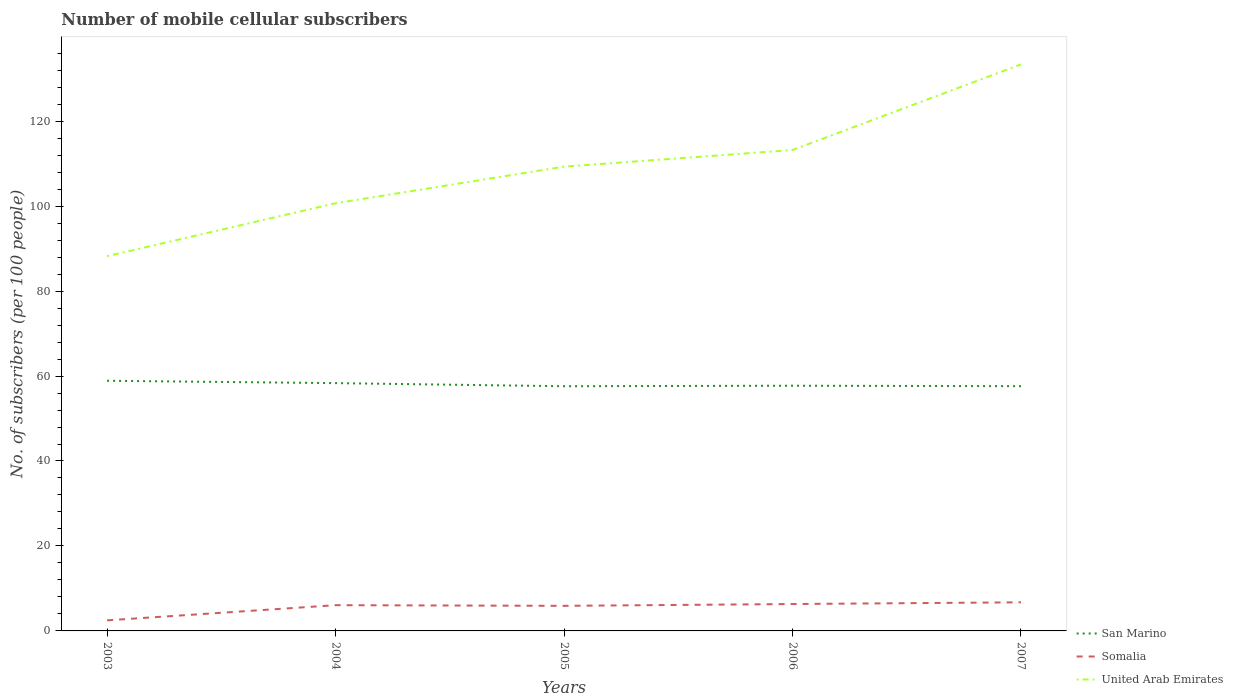How many different coloured lines are there?
Provide a succinct answer. 3. Across all years, what is the maximum number of mobile cellular subscribers in United Arab Emirates?
Your answer should be compact. 88.22. In which year was the number of mobile cellular subscribers in Somalia maximum?
Keep it short and to the point. 2003. What is the total number of mobile cellular subscribers in Somalia in the graph?
Your answer should be very brief. -3.42. What is the difference between the highest and the second highest number of mobile cellular subscribers in San Marino?
Your response must be concise. 1.29. What is the difference between the highest and the lowest number of mobile cellular subscribers in Somalia?
Your answer should be very brief. 4. How many years are there in the graph?
Your response must be concise. 5. Where does the legend appear in the graph?
Give a very brief answer. Bottom right. How are the legend labels stacked?
Keep it short and to the point. Vertical. What is the title of the graph?
Offer a terse response. Number of mobile cellular subscribers. What is the label or title of the X-axis?
Your answer should be very brief. Years. What is the label or title of the Y-axis?
Ensure brevity in your answer.  No. of subscribers (per 100 people). What is the No. of subscribers (per 100 people) of San Marino in 2003?
Give a very brief answer. 58.89. What is the No. of subscribers (per 100 people) in Somalia in 2003?
Provide a succinct answer. 2.49. What is the No. of subscribers (per 100 people) of United Arab Emirates in 2003?
Your answer should be compact. 88.22. What is the No. of subscribers (per 100 people) in San Marino in 2004?
Your answer should be very brief. 58.33. What is the No. of subscribers (per 100 people) of Somalia in 2004?
Ensure brevity in your answer.  6.06. What is the No. of subscribers (per 100 people) in United Arab Emirates in 2004?
Provide a succinct answer. 100.67. What is the No. of subscribers (per 100 people) in San Marino in 2005?
Your answer should be very brief. 57.6. What is the No. of subscribers (per 100 people) in Somalia in 2005?
Ensure brevity in your answer.  5.91. What is the No. of subscribers (per 100 people) of United Arab Emirates in 2005?
Your response must be concise. 109.29. What is the No. of subscribers (per 100 people) in San Marino in 2006?
Ensure brevity in your answer.  57.72. What is the No. of subscribers (per 100 people) in Somalia in 2006?
Give a very brief answer. 6.33. What is the No. of subscribers (per 100 people) of United Arab Emirates in 2006?
Give a very brief answer. 113.2. What is the No. of subscribers (per 100 people) in San Marino in 2007?
Provide a succinct answer. 57.61. What is the No. of subscribers (per 100 people) in Somalia in 2007?
Make the answer very short. 6.73. What is the No. of subscribers (per 100 people) of United Arab Emirates in 2007?
Your answer should be compact. 133.36. Across all years, what is the maximum No. of subscribers (per 100 people) of San Marino?
Your answer should be very brief. 58.89. Across all years, what is the maximum No. of subscribers (per 100 people) of Somalia?
Offer a very short reply. 6.73. Across all years, what is the maximum No. of subscribers (per 100 people) of United Arab Emirates?
Your answer should be compact. 133.36. Across all years, what is the minimum No. of subscribers (per 100 people) of San Marino?
Ensure brevity in your answer.  57.6. Across all years, what is the minimum No. of subscribers (per 100 people) of Somalia?
Provide a succinct answer. 2.49. Across all years, what is the minimum No. of subscribers (per 100 people) of United Arab Emirates?
Offer a terse response. 88.22. What is the total No. of subscribers (per 100 people) of San Marino in the graph?
Offer a very short reply. 290.14. What is the total No. of subscribers (per 100 people) of Somalia in the graph?
Your answer should be compact. 27.52. What is the total No. of subscribers (per 100 people) in United Arab Emirates in the graph?
Make the answer very short. 544.74. What is the difference between the No. of subscribers (per 100 people) of San Marino in 2003 and that in 2004?
Offer a terse response. 0.55. What is the difference between the No. of subscribers (per 100 people) of Somalia in 2003 and that in 2004?
Make the answer very short. -3.57. What is the difference between the No. of subscribers (per 100 people) of United Arab Emirates in 2003 and that in 2004?
Provide a succinct answer. -12.45. What is the difference between the No. of subscribers (per 100 people) in San Marino in 2003 and that in 2005?
Your response must be concise. 1.29. What is the difference between the No. of subscribers (per 100 people) in Somalia in 2003 and that in 2005?
Offer a terse response. -3.42. What is the difference between the No. of subscribers (per 100 people) of United Arab Emirates in 2003 and that in 2005?
Your response must be concise. -21.07. What is the difference between the No. of subscribers (per 100 people) in San Marino in 2003 and that in 2006?
Make the answer very short. 1.17. What is the difference between the No. of subscribers (per 100 people) in Somalia in 2003 and that in 2006?
Your answer should be very brief. -3.84. What is the difference between the No. of subscribers (per 100 people) of United Arab Emirates in 2003 and that in 2006?
Provide a short and direct response. -24.98. What is the difference between the No. of subscribers (per 100 people) in San Marino in 2003 and that in 2007?
Your response must be concise. 1.28. What is the difference between the No. of subscribers (per 100 people) of Somalia in 2003 and that in 2007?
Your answer should be compact. -4.25. What is the difference between the No. of subscribers (per 100 people) in United Arab Emirates in 2003 and that in 2007?
Your response must be concise. -45.14. What is the difference between the No. of subscribers (per 100 people) of San Marino in 2004 and that in 2005?
Ensure brevity in your answer.  0.73. What is the difference between the No. of subscribers (per 100 people) in Somalia in 2004 and that in 2005?
Your response must be concise. 0.16. What is the difference between the No. of subscribers (per 100 people) of United Arab Emirates in 2004 and that in 2005?
Offer a very short reply. -8.62. What is the difference between the No. of subscribers (per 100 people) of San Marino in 2004 and that in 2006?
Keep it short and to the point. 0.61. What is the difference between the No. of subscribers (per 100 people) in Somalia in 2004 and that in 2006?
Offer a terse response. -0.27. What is the difference between the No. of subscribers (per 100 people) in United Arab Emirates in 2004 and that in 2006?
Your answer should be compact. -12.53. What is the difference between the No. of subscribers (per 100 people) in San Marino in 2004 and that in 2007?
Your answer should be very brief. 0.72. What is the difference between the No. of subscribers (per 100 people) of Somalia in 2004 and that in 2007?
Your answer should be very brief. -0.67. What is the difference between the No. of subscribers (per 100 people) of United Arab Emirates in 2004 and that in 2007?
Make the answer very short. -32.69. What is the difference between the No. of subscribers (per 100 people) of San Marino in 2005 and that in 2006?
Keep it short and to the point. -0.12. What is the difference between the No. of subscribers (per 100 people) in Somalia in 2005 and that in 2006?
Offer a very short reply. -0.43. What is the difference between the No. of subscribers (per 100 people) of United Arab Emirates in 2005 and that in 2006?
Offer a terse response. -3.92. What is the difference between the No. of subscribers (per 100 people) in San Marino in 2005 and that in 2007?
Offer a very short reply. -0.01. What is the difference between the No. of subscribers (per 100 people) in Somalia in 2005 and that in 2007?
Ensure brevity in your answer.  -0.83. What is the difference between the No. of subscribers (per 100 people) in United Arab Emirates in 2005 and that in 2007?
Your response must be concise. -24.08. What is the difference between the No. of subscribers (per 100 people) in San Marino in 2006 and that in 2007?
Provide a short and direct response. 0.11. What is the difference between the No. of subscribers (per 100 people) in Somalia in 2006 and that in 2007?
Provide a short and direct response. -0.4. What is the difference between the No. of subscribers (per 100 people) in United Arab Emirates in 2006 and that in 2007?
Provide a short and direct response. -20.16. What is the difference between the No. of subscribers (per 100 people) in San Marino in 2003 and the No. of subscribers (per 100 people) in Somalia in 2004?
Offer a terse response. 52.82. What is the difference between the No. of subscribers (per 100 people) of San Marino in 2003 and the No. of subscribers (per 100 people) of United Arab Emirates in 2004?
Offer a terse response. -41.78. What is the difference between the No. of subscribers (per 100 people) in Somalia in 2003 and the No. of subscribers (per 100 people) in United Arab Emirates in 2004?
Make the answer very short. -98.18. What is the difference between the No. of subscribers (per 100 people) of San Marino in 2003 and the No. of subscribers (per 100 people) of Somalia in 2005?
Offer a very short reply. 52.98. What is the difference between the No. of subscribers (per 100 people) of San Marino in 2003 and the No. of subscribers (per 100 people) of United Arab Emirates in 2005?
Your response must be concise. -50.4. What is the difference between the No. of subscribers (per 100 people) in Somalia in 2003 and the No. of subscribers (per 100 people) in United Arab Emirates in 2005?
Your response must be concise. -106.8. What is the difference between the No. of subscribers (per 100 people) in San Marino in 2003 and the No. of subscribers (per 100 people) in Somalia in 2006?
Offer a terse response. 52.55. What is the difference between the No. of subscribers (per 100 people) in San Marino in 2003 and the No. of subscribers (per 100 people) in United Arab Emirates in 2006?
Offer a very short reply. -54.32. What is the difference between the No. of subscribers (per 100 people) in Somalia in 2003 and the No. of subscribers (per 100 people) in United Arab Emirates in 2006?
Give a very brief answer. -110.71. What is the difference between the No. of subscribers (per 100 people) in San Marino in 2003 and the No. of subscribers (per 100 people) in Somalia in 2007?
Your answer should be compact. 52.15. What is the difference between the No. of subscribers (per 100 people) in San Marino in 2003 and the No. of subscribers (per 100 people) in United Arab Emirates in 2007?
Offer a very short reply. -74.48. What is the difference between the No. of subscribers (per 100 people) of Somalia in 2003 and the No. of subscribers (per 100 people) of United Arab Emirates in 2007?
Keep it short and to the point. -130.87. What is the difference between the No. of subscribers (per 100 people) of San Marino in 2004 and the No. of subscribers (per 100 people) of Somalia in 2005?
Keep it short and to the point. 52.43. What is the difference between the No. of subscribers (per 100 people) in San Marino in 2004 and the No. of subscribers (per 100 people) in United Arab Emirates in 2005?
Offer a very short reply. -50.96. What is the difference between the No. of subscribers (per 100 people) of Somalia in 2004 and the No. of subscribers (per 100 people) of United Arab Emirates in 2005?
Your response must be concise. -103.23. What is the difference between the No. of subscribers (per 100 people) in San Marino in 2004 and the No. of subscribers (per 100 people) in Somalia in 2006?
Your answer should be very brief. 52. What is the difference between the No. of subscribers (per 100 people) in San Marino in 2004 and the No. of subscribers (per 100 people) in United Arab Emirates in 2006?
Offer a terse response. -54.87. What is the difference between the No. of subscribers (per 100 people) of Somalia in 2004 and the No. of subscribers (per 100 people) of United Arab Emirates in 2006?
Your answer should be compact. -107.14. What is the difference between the No. of subscribers (per 100 people) in San Marino in 2004 and the No. of subscribers (per 100 people) in Somalia in 2007?
Ensure brevity in your answer.  51.6. What is the difference between the No. of subscribers (per 100 people) in San Marino in 2004 and the No. of subscribers (per 100 people) in United Arab Emirates in 2007?
Provide a short and direct response. -75.03. What is the difference between the No. of subscribers (per 100 people) in Somalia in 2004 and the No. of subscribers (per 100 people) in United Arab Emirates in 2007?
Ensure brevity in your answer.  -127.3. What is the difference between the No. of subscribers (per 100 people) in San Marino in 2005 and the No. of subscribers (per 100 people) in Somalia in 2006?
Your answer should be compact. 51.27. What is the difference between the No. of subscribers (per 100 people) in San Marino in 2005 and the No. of subscribers (per 100 people) in United Arab Emirates in 2006?
Provide a succinct answer. -55.6. What is the difference between the No. of subscribers (per 100 people) of Somalia in 2005 and the No. of subscribers (per 100 people) of United Arab Emirates in 2006?
Your answer should be very brief. -107.3. What is the difference between the No. of subscribers (per 100 people) of San Marino in 2005 and the No. of subscribers (per 100 people) of Somalia in 2007?
Your answer should be very brief. 50.87. What is the difference between the No. of subscribers (per 100 people) in San Marino in 2005 and the No. of subscribers (per 100 people) in United Arab Emirates in 2007?
Provide a short and direct response. -75.76. What is the difference between the No. of subscribers (per 100 people) in Somalia in 2005 and the No. of subscribers (per 100 people) in United Arab Emirates in 2007?
Make the answer very short. -127.46. What is the difference between the No. of subscribers (per 100 people) of San Marino in 2006 and the No. of subscribers (per 100 people) of Somalia in 2007?
Ensure brevity in your answer.  50.98. What is the difference between the No. of subscribers (per 100 people) in San Marino in 2006 and the No. of subscribers (per 100 people) in United Arab Emirates in 2007?
Your answer should be compact. -75.65. What is the difference between the No. of subscribers (per 100 people) in Somalia in 2006 and the No. of subscribers (per 100 people) in United Arab Emirates in 2007?
Keep it short and to the point. -127.03. What is the average No. of subscribers (per 100 people) of San Marino per year?
Provide a short and direct response. 58.03. What is the average No. of subscribers (per 100 people) of Somalia per year?
Give a very brief answer. 5.5. What is the average No. of subscribers (per 100 people) in United Arab Emirates per year?
Your response must be concise. 108.95. In the year 2003, what is the difference between the No. of subscribers (per 100 people) of San Marino and No. of subscribers (per 100 people) of Somalia?
Offer a very short reply. 56.4. In the year 2003, what is the difference between the No. of subscribers (per 100 people) in San Marino and No. of subscribers (per 100 people) in United Arab Emirates?
Your response must be concise. -29.33. In the year 2003, what is the difference between the No. of subscribers (per 100 people) in Somalia and No. of subscribers (per 100 people) in United Arab Emirates?
Give a very brief answer. -85.73. In the year 2004, what is the difference between the No. of subscribers (per 100 people) of San Marino and No. of subscribers (per 100 people) of Somalia?
Give a very brief answer. 52.27. In the year 2004, what is the difference between the No. of subscribers (per 100 people) in San Marino and No. of subscribers (per 100 people) in United Arab Emirates?
Your answer should be compact. -42.34. In the year 2004, what is the difference between the No. of subscribers (per 100 people) of Somalia and No. of subscribers (per 100 people) of United Arab Emirates?
Provide a short and direct response. -94.61. In the year 2005, what is the difference between the No. of subscribers (per 100 people) of San Marino and No. of subscribers (per 100 people) of Somalia?
Give a very brief answer. 51.69. In the year 2005, what is the difference between the No. of subscribers (per 100 people) of San Marino and No. of subscribers (per 100 people) of United Arab Emirates?
Give a very brief answer. -51.69. In the year 2005, what is the difference between the No. of subscribers (per 100 people) of Somalia and No. of subscribers (per 100 people) of United Arab Emirates?
Keep it short and to the point. -103.38. In the year 2006, what is the difference between the No. of subscribers (per 100 people) of San Marino and No. of subscribers (per 100 people) of Somalia?
Keep it short and to the point. 51.39. In the year 2006, what is the difference between the No. of subscribers (per 100 people) of San Marino and No. of subscribers (per 100 people) of United Arab Emirates?
Offer a terse response. -55.48. In the year 2006, what is the difference between the No. of subscribers (per 100 people) in Somalia and No. of subscribers (per 100 people) in United Arab Emirates?
Provide a short and direct response. -106.87. In the year 2007, what is the difference between the No. of subscribers (per 100 people) in San Marino and No. of subscribers (per 100 people) in Somalia?
Offer a terse response. 50.88. In the year 2007, what is the difference between the No. of subscribers (per 100 people) in San Marino and No. of subscribers (per 100 people) in United Arab Emirates?
Ensure brevity in your answer.  -75.75. In the year 2007, what is the difference between the No. of subscribers (per 100 people) in Somalia and No. of subscribers (per 100 people) in United Arab Emirates?
Your answer should be very brief. -126.63. What is the ratio of the No. of subscribers (per 100 people) in San Marino in 2003 to that in 2004?
Your response must be concise. 1.01. What is the ratio of the No. of subscribers (per 100 people) of Somalia in 2003 to that in 2004?
Offer a terse response. 0.41. What is the ratio of the No. of subscribers (per 100 people) of United Arab Emirates in 2003 to that in 2004?
Ensure brevity in your answer.  0.88. What is the ratio of the No. of subscribers (per 100 people) in San Marino in 2003 to that in 2005?
Offer a very short reply. 1.02. What is the ratio of the No. of subscribers (per 100 people) of Somalia in 2003 to that in 2005?
Give a very brief answer. 0.42. What is the ratio of the No. of subscribers (per 100 people) of United Arab Emirates in 2003 to that in 2005?
Your answer should be compact. 0.81. What is the ratio of the No. of subscribers (per 100 people) in San Marino in 2003 to that in 2006?
Your answer should be compact. 1.02. What is the ratio of the No. of subscribers (per 100 people) in Somalia in 2003 to that in 2006?
Your answer should be very brief. 0.39. What is the ratio of the No. of subscribers (per 100 people) of United Arab Emirates in 2003 to that in 2006?
Provide a short and direct response. 0.78. What is the ratio of the No. of subscribers (per 100 people) in San Marino in 2003 to that in 2007?
Offer a very short reply. 1.02. What is the ratio of the No. of subscribers (per 100 people) of Somalia in 2003 to that in 2007?
Your response must be concise. 0.37. What is the ratio of the No. of subscribers (per 100 people) in United Arab Emirates in 2003 to that in 2007?
Provide a succinct answer. 0.66. What is the ratio of the No. of subscribers (per 100 people) of San Marino in 2004 to that in 2005?
Your answer should be very brief. 1.01. What is the ratio of the No. of subscribers (per 100 people) of Somalia in 2004 to that in 2005?
Ensure brevity in your answer.  1.03. What is the ratio of the No. of subscribers (per 100 people) in United Arab Emirates in 2004 to that in 2005?
Offer a very short reply. 0.92. What is the ratio of the No. of subscribers (per 100 people) of San Marino in 2004 to that in 2006?
Your answer should be very brief. 1.01. What is the ratio of the No. of subscribers (per 100 people) in Somalia in 2004 to that in 2006?
Offer a terse response. 0.96. What is the ratio of the No. of subscribers (per 100 people) in United Arab Emirates in 2004 to that in 2006?
Your response must be concise. 0.89. What is the ratio of the No. of subscribers (per 100 people) of San Marino in 2004 to that in 2007?
Your response must be concise. 1.01. What is the ratio of the No. of subscribers (per 100 people) of Somalia in 2004 to that in 2007?
Provide a short and direct response. 0.9. What is the ratio of the No. of subscribers (per 100 people) in United Arab Emirates in 2004 to that in 2007?
Provide a short and direct response. 0.75. What is the ratio of the No. of subscribers (per 100 people) of San Marino in 2005 to that in 2006?
Ensure brevity in your answer.  1. What is the ratio of the No. of subscribers (per 100 people) in Somalia in 2005 to that in 2006?
Provide a short and direct response. 0.93. What is the ratio of the No. of subscribers (per 100 people) of United Arab Emirates in 2005 to that in 2006?
Your answer should be compact. 0.97. What is the ratio of the No. of subscribers (per 100 people) of San Marino in 2005 to that in 2007?
Make the answer very short. 1. What is the ratio of the No. of subscribers (per 100 people) in Somalia in 2005 to that in 2007?
Your response must be concise. 0.88. What is the ratio of the No. of subscribers (per 100 people) of United Arab Emirates in 2005 to that in 2007?
Your response must be concise. 0.82. What is the ratio of the No. of subscribers (per 100 people) of San Marino in 2006 to that in 2007?
Offer a terse response. 1. What is the ratio of the No. of subscribers (per 100 people) of Somalia in 2006 to that in 2007?
Make the answer very short. 0.94. What is the ratio of the No. of subscribers (per 100 people) in United Arab Emirates in 2006 to that in 2007?
Ensure brevity in your answer.  0.85. What is the difference between the highest and the second highest No. of subscribers (per 100 people) in San Marino?
Give a very brief answer. 0.55. What is the difference between the highest and the second highest No. of subscribers (per 100 people) in Somalia?
Your answer should be very brief. 0.4. What is the difference between the highest and the second highest No. of subscribers (per 100 people) of United Arab Emirates?
Your response must be concise. 20.16. What is the difference between the highest and the lowest No. of subscribers (per 100 people) of San Marino?
Provide a short and direct response. 1.29. What is the difference between the highest and the lowest No. of subscribers (per 100 people) in Somalia?
Your answer should be compact. 4.25. What is the difference between the highest and the lowest No. of subscribers (per 100 people) of United Arab Emirates?
Keep it short and to the point. 45.14. 